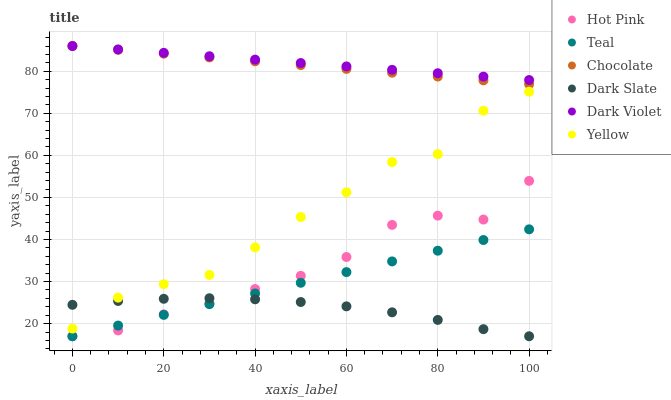Does Dark Slate have the minimum area under the curve?
Answer yes or no. Yes. Does Dark Violet have the maximum area under the curve?
Answer yes or no. Yes. Does Yellow have the minimum area under the curve?
Answer yes or no. No. Does Yellow have the maximum area under the curve?
Answer yes or no. No. Is Teal the smoothest?
Answer yes or no. Yes. Is Yellow the roughest?
Answer yes or no. Yes. Is Chocolate the smoothest?
Answer yes or no. No. Is Chocolate the roughest?
Answer yes or no. No. Does Hot Pink have the lowest value?
Answer yes or no. Yes. Does Yellow have the lowest value?
Answer yes or no. No. Does Dark Violet have the highest value?
Answer yes or no. Yes. Does Yellow have the highest value?
Answer yes or no. No. Is Hot Pink less than Dark Violet?
Answer yes or no. Yes. Is Dark Violet greater than Teal?
Answer yes or no. Yes. Does Chocolate intersect Dark Violet?
Answer yes or no. Yes. Is Chocolate less than Dark Violet?
Answer yes or no. No. Is Chocolate greater than Dark Violet?
Answer yes or no. No. Does Hot Pink intersect Dark Violet?
Answer yes or no. No. 